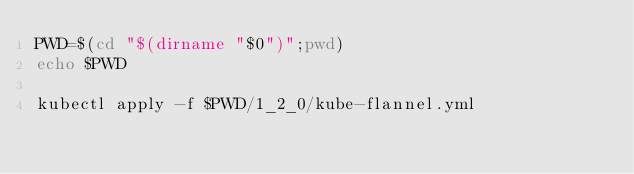Convert code to text. <code><loc_0><loc_0><loc_500><loc_500><_Bash_>PWD=$(cd "$(dirname "$0")";pwd)
echo $PWD

kubectl apply -f $PWD/1_2_0/kube-flannel.yml

</code> 